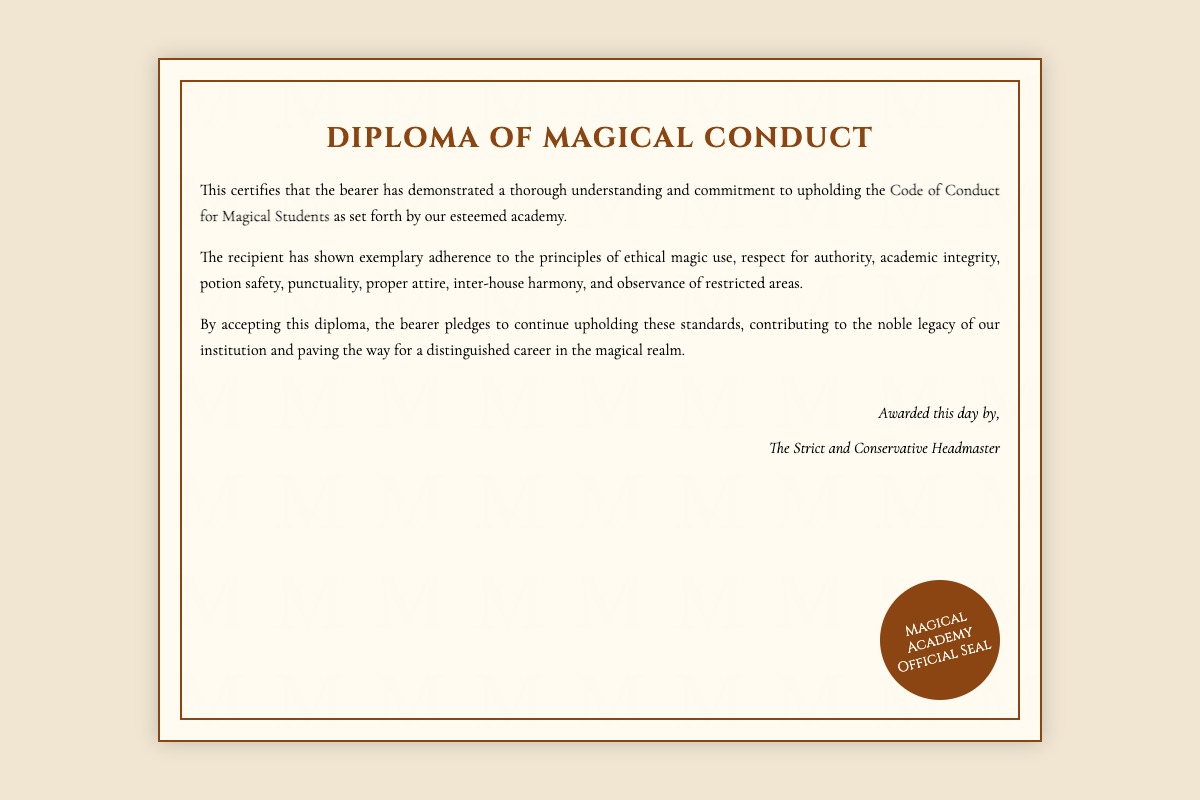what is the title of the document? The title of the document is prominently displayed at the top and indicates the purpose of the diploma.
Answer: Diploma of Magical Conduct who awarded the diploma? The name of the person who awarded the diploma can be found in the signature section of the document.
Answer: The Strict and Conservative Headmaster what is the primary subject of the diploma? The diploma certifies the recipient's understanding and commitment to a specific set of guidelines.
Answer: Code of Conduct for Magical Students what are two principles the recipient has adhered to? The document lists multiple principles related to ethical behavior and responsibilities of magical students.
Answer: ethical magic use, respect for authority what is the significance of this diploma? The document outlines the contribution and commitment of the recipient to their magical education due to the standards upheld.
Answer: Upbringing of a distinguished career in the magical realm how many sections does the content of the diploma contain? Analyzing the content, it consists of three distinct paragraphs.
Answer: Three where is the official seal located? The location of the seal is specified in the layout of the diploma.
Answer: Bottom right corner when was the diploma awarded? The document indicates the award but does not specify an exact date, using the phrase “this day.”
Answer: this day 